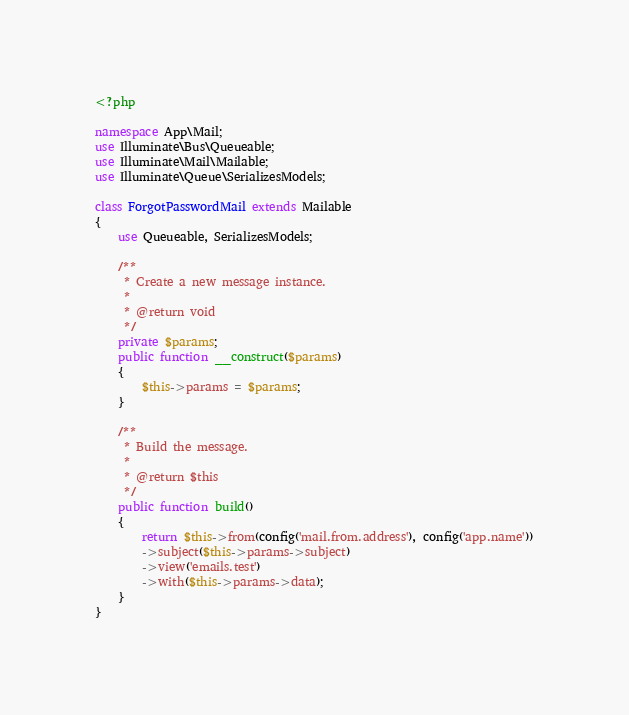<code> <loc_0><loc_0><loc_500><loc_500><_PHP_><?php

namespace App\Mail;
use Illuminate\Bus\Queueable;
use Illuminate\Mail\Mailable;
use Illuminate\Queue\SerializesModels;

class ForgotPasswordMail extends Mailable
{
    use Queueable, SerializesModels;

    /**
     * Create a new message instance.
     *
     * @return void
     */
    private $params;
    public function __construct($params)
    {
        $this->params = $params;
    }

    /**
     * Build the message.
     *
     * @return $this
     */
    public function build()
    {
        return $this->from(config('mail.from.address'), config('app.name'))
        ->subject($this->params->subject)
        ->view('emails.test')
        ->with($this->params->data);
    }
}
</code> 